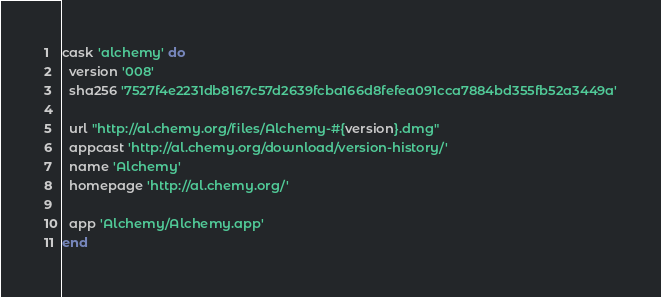Convert code to text. <code><loc_0><loc_0><loc_500><loc_500><_Ruby_>cask 'alchemy' do
  version '008'
  sha256 '7527f4e2231db8167c57d2639fcba166d8fefea091cca7884bd355fb52a3449a'

  url "http://al.chemy.org/files/Alchemy-#{version}.dmg"
  appcast 'http://al.chemy.org/download/version-history/'
  name 'Alchemy'
  homepage 'http://al.chemy.org/'

  app 'Alchemy/Alchemy.app'
end
</code> 